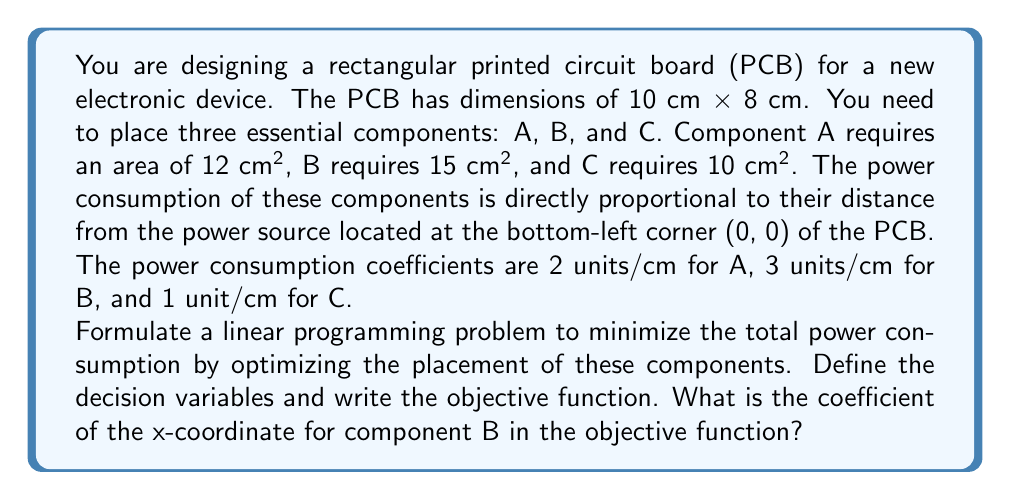Could you help me with this problem? Let's approach this step-by-step:

1) First, we need to define our decision variables. Let $(x_A, y_A)$, $(x_B, y_B)$, and $(x_C, y_C)$ be the coordinates of the center points of components A, B, and C respectively.

2) The objective is to minimize the total power consumption. The power consumption for each component is proportional to its distance from (0, 0) and its coefficient. The distance can be calculated using the Manhattan distance (sum of x and y coordinates) for simplicity in linear programming.

3) The objective function will be:

   Minimize: $2(x_A + y_A) + 3(x_B + y_B) + (x_C + y_C)$

4) We can expand this to:

   Minimize: $2x_A + 2y_A + 3x_B + 3y_B + x_C + y_C$

5) The constraints would include:
   - Area constraints: $12 \leq x_A \cdot y_A \leq 12$, $15 \leq x_B \cdot y_B \leq 15$, $10 \leq x_C \cdot y_C \leq 10$
   - Boundary constraints: $0 \leq x_A, x_B, x_C \leq 10$ and $0 \leq y_A, y_B, y_C \leq 8$
   - Non-overlapping constraints (which would be non-linear and need to be linearized)

6) Looking at the objective function, we can see that the coefficient of $x_B$ is 3.
Answer: 3 